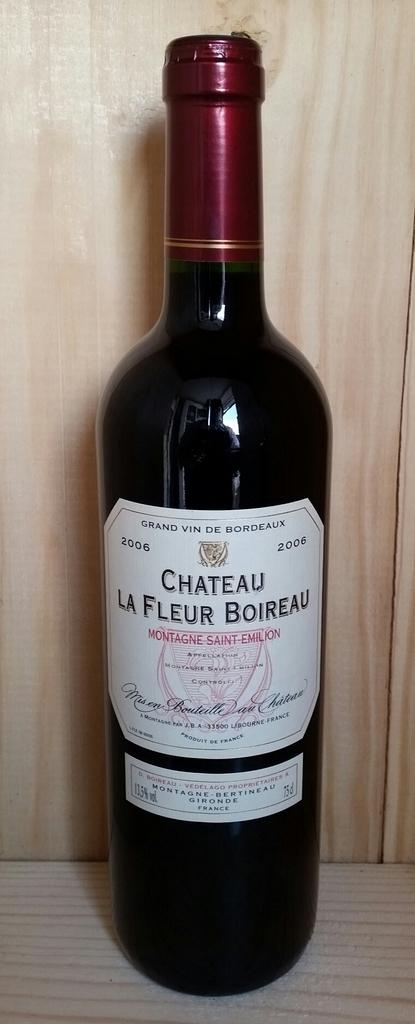<image>
Summarize the visual content of the image. A bottle of Chateau La Fleur Boireau wine. 